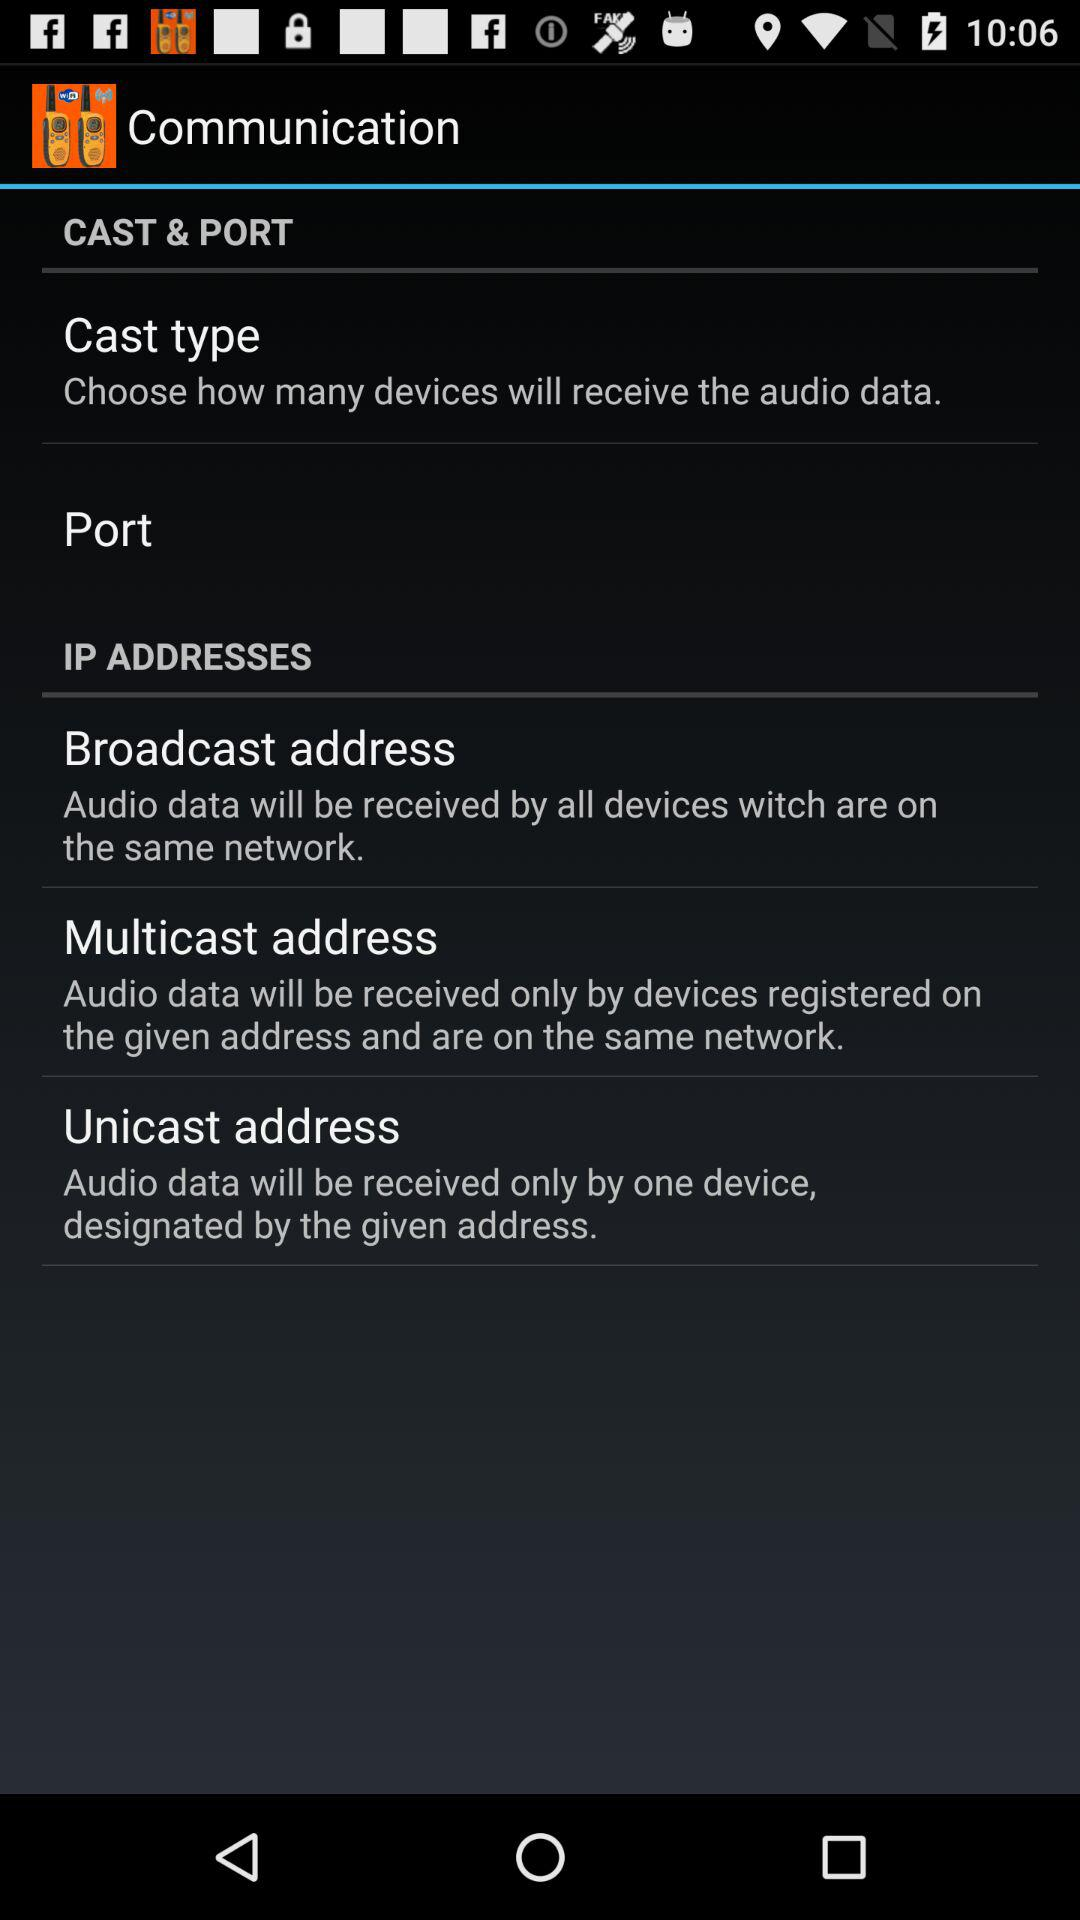How many types of cast are there?
Answer the question using a single word or phrase. 3 